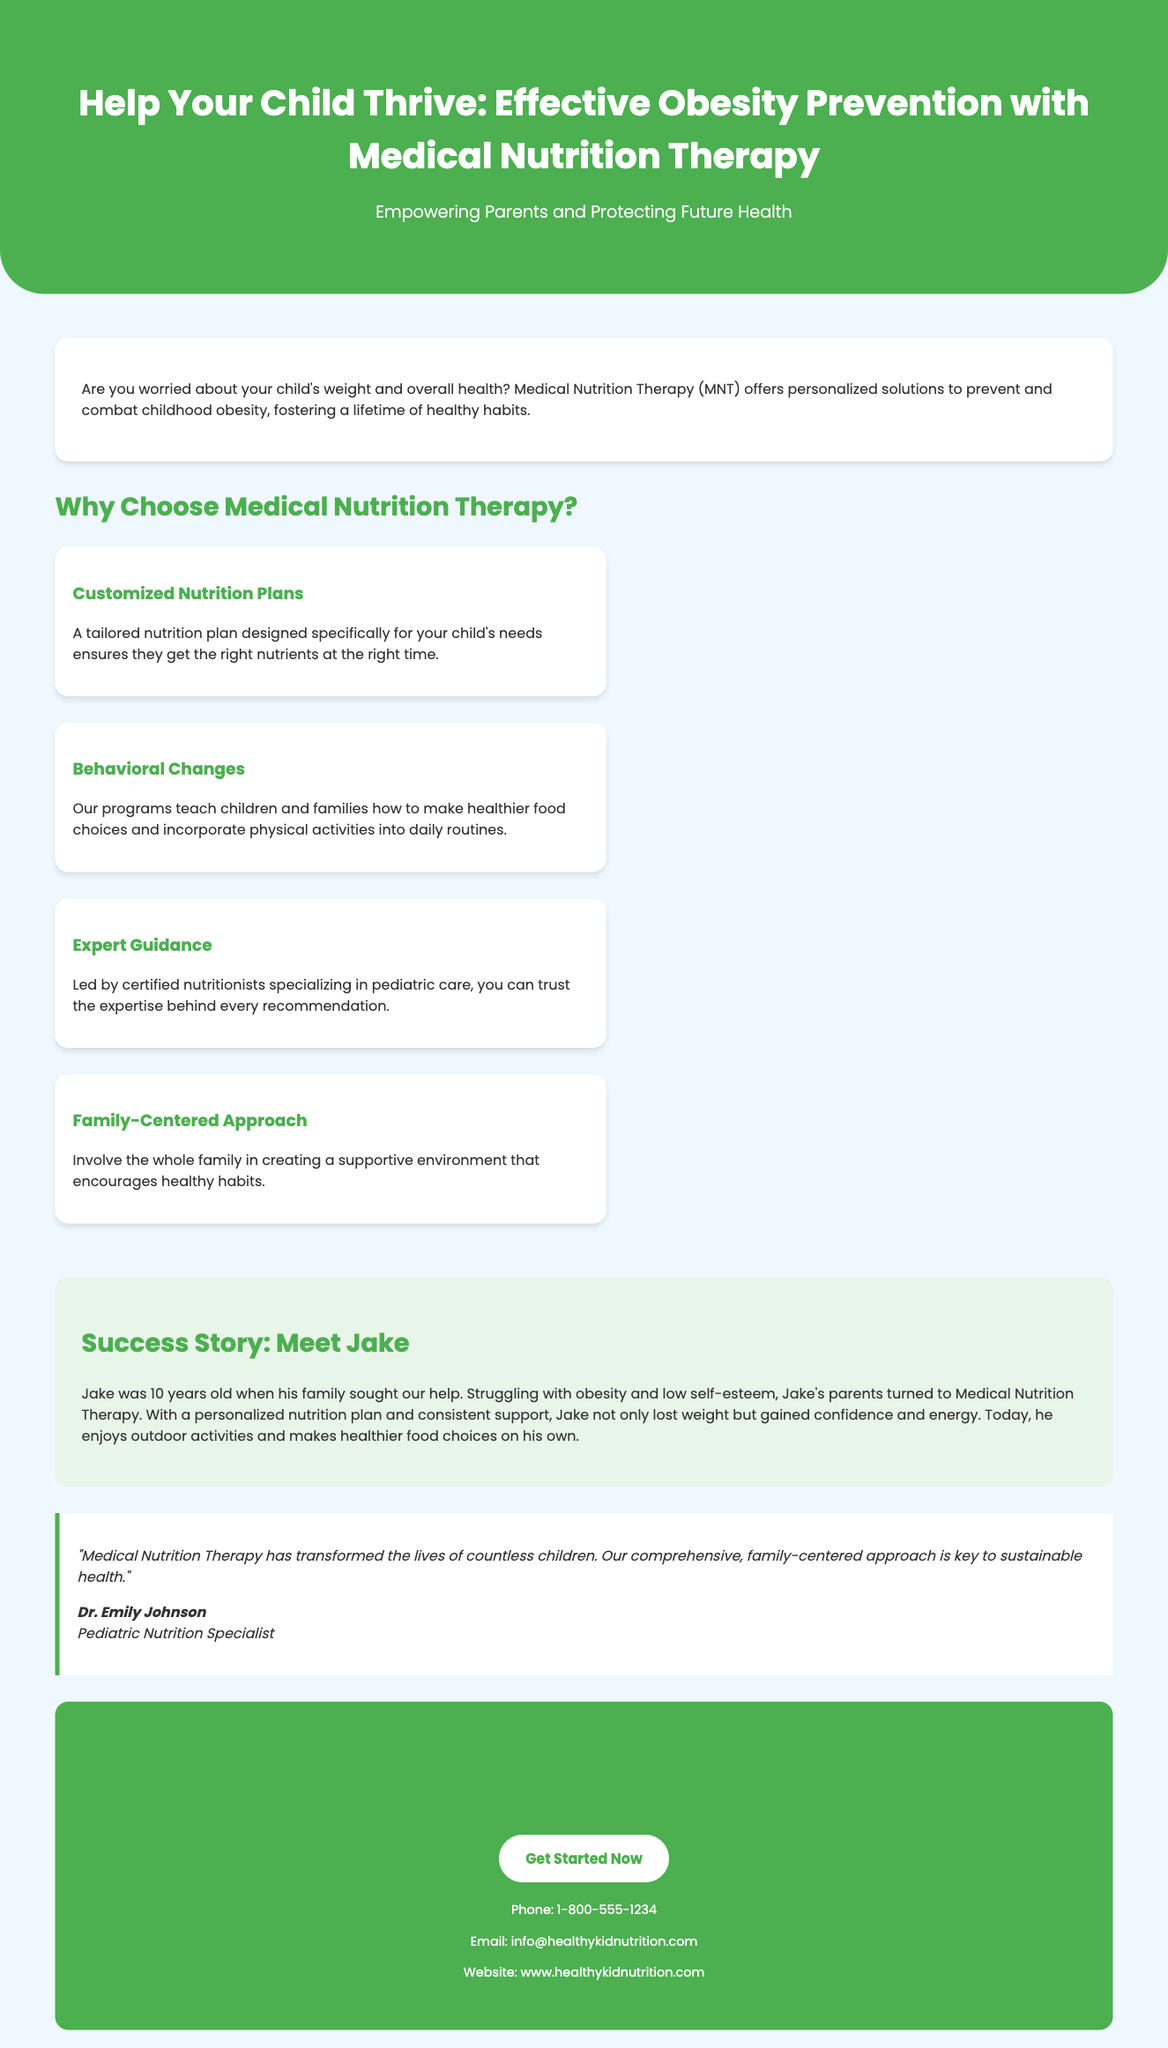What is the title of the advertisement? The title clearly states the purpose of the advertisement as mentioned in the header section.
Answer: Help Your Child Thrive: Effective Obesity Prevention with Medical Nutrition Therapy Who is the pediatric nutrition specialist quoted in the endorsement? The endorsement section includes a quote and provides the name of the specialist.
Answer: Dr. Emily Johnson What age was Jake when he started the program? The success story mentions Jake's age when his family sought help.
Answer: 10 years old What is one of the benefits of Medical Nutrition Therapy? The benefits section lists several advantages, one of which is highlighted.
Answer: Customized Nutrition Plans What is the phone number provided for contact? The contact information section has a dedicated line for inquiries about the program.
Answer: 1-800-555-1234 What type of approach does the program emphasize? The description of one of the benefits explicitly mentions a type of familial involvement.
Answer: Family-Centered Approach How can families initiate the program? The call to action at the end of the document encourages immediate action from families.
Answer: Get Started Now 